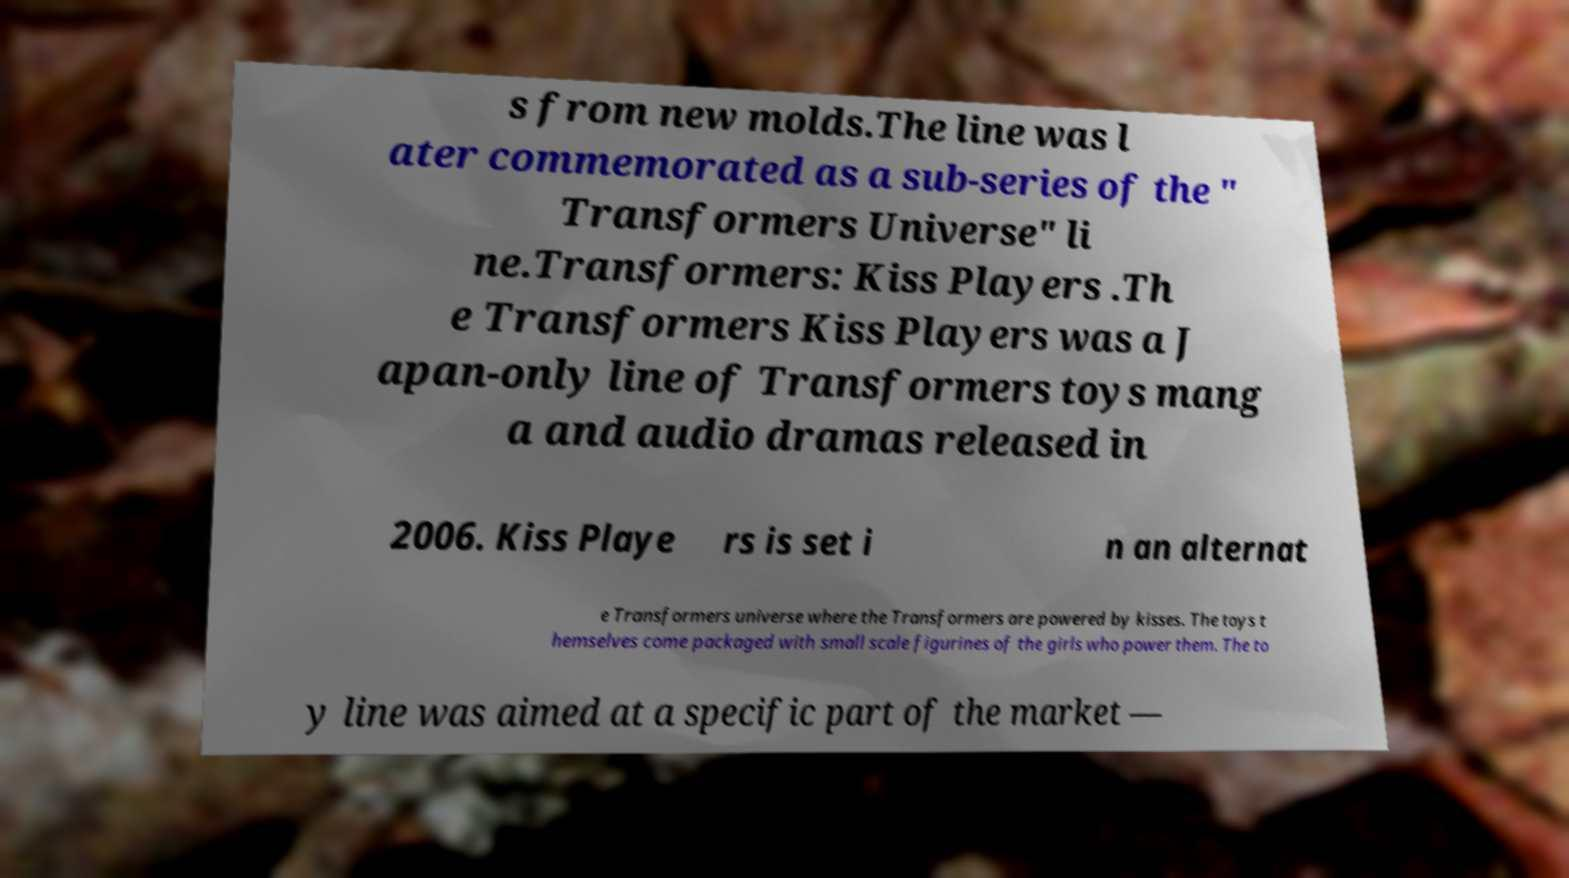For documentation purposes, I need the text within this image transcribed. Could you provide that? s from new molds.The line was l ater commemorated as a sub-series of the " Transformers Universe" li ne.Transformers: Kiss Players .Th e Transformers Kiss Players was a J apan-only line of Transformers toys mang a and audio dramas released in 2006. Kiss Playe rs is set i n an alternat e Transformers universe where the Transformers are powered by kisses. The toys t hemselves come packaged with small scale figurines of the girls who power them. The to y line was aimed at a specific part of the market — 